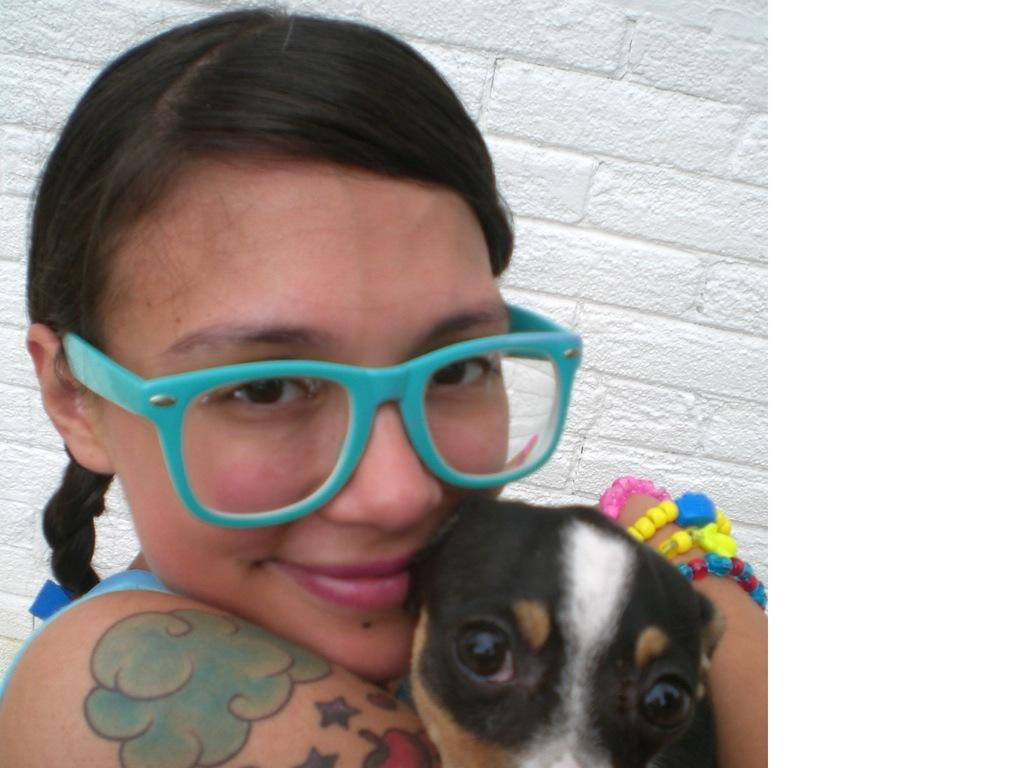Who is the main subject in the image? There is a girl in the image. What is the girl holding in the image? The girl is holding a dog. Can you describe the girl's appearance? The girl is wearing specs. What can be seen in the background of the image? There is a white wall in the background of the image. What type of grain can be seen on the library shelves in the image? There is no grain or library present in the image; it features a girl holding a dog with a white wall in the background. 